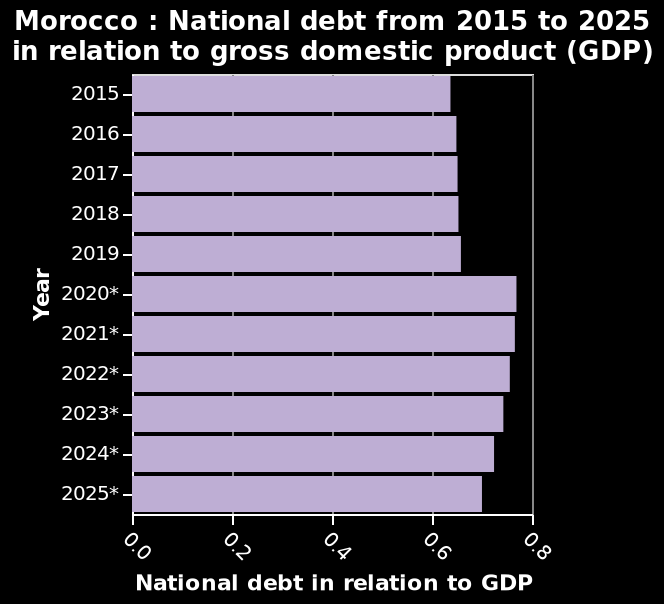<image>
What is the range of the x-axis scale?  The x-axis scale ranges from 0.0 to 0.8. What does the y-axis represent in the bar diagram?  The y-axis represents "Year" in the bar diagram. Offer a thorough analysis of the image. The chart shows that national debt in Morocco (in relation to GDP) hit an all time high. The chart also shows that there are predictions that national debt will decrease by 2025. What is the current state of national debt in Morocco?  The current state of national debt in Morocco is at an all-time high, as shown in the chart. Is the national debt in Morocco currently at a sustainable level? Based on the information provided, it is not clear whether the national debt in Morocco is currently at a sustainable level or not. How does the national debt in Morocco compare to the GDP?  The chart shows that the national debt in Morocco is measured in relation to the GDP. 